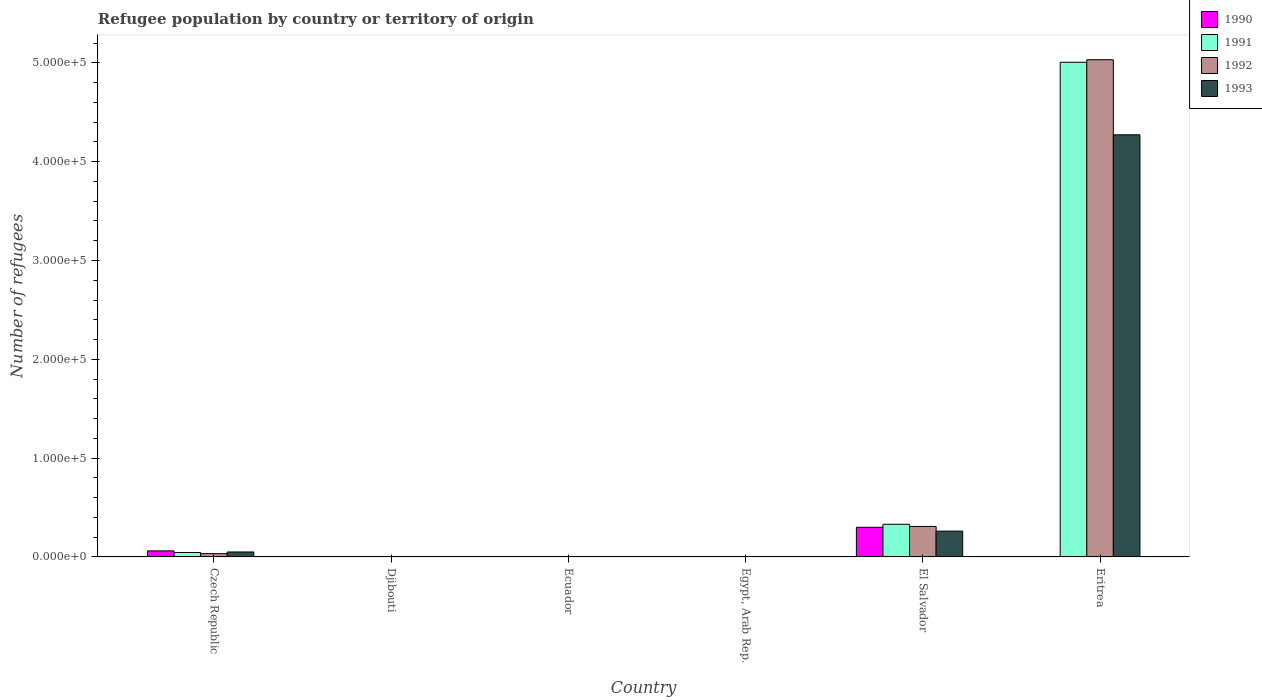How many different coloured bars are there?
Offer a very short reply. 4. Are the number of bars per tick equal to the number of legend labels?
Offer a very short reply. Yes. What is the label of the 4th group of bars from the left?
Make the answer very short. Egypt, Arab Rep. In how many cases, is the number of bars for a given country not equal to the number of legend labels?
Your answer should be compact. 0. Across all countries, what is the maximum number of refugees in 1990?
Make the answer very short. 3.00e+04. In which country was the number of refugees in 1990 maximum?
Offer a very short reply. El Salvador. In which country was the number of refugees in 1990 minimum?
Give a very brief answer. Ecuador. What is the total number of refugees in 1990 in the graph?
Your answer should be compact. 3.62e+04. What is the difference between the number of refugees in 1991 in Djibouti and that in Egypt, Arab Rep.?
Make the answer very short. -87. What is the difference between the number of refugees in 1992 in Czech Republic and the number of refugees in 1990 in Ecuador?
Offer a very short reply. 3324. What is the average number of refugees in 1990 per country?
Make the answer very short. 6040.17. What is the difference between the number of refugees of/in 1992 and number of refugees of/in 1991 in El Salvador?
Provide a short and direct response. -2194. In how many countries, is the number of refugees in 1991 greater than 360000?
Provide a short and direct response. 1. What is the ratio of the number of refugees in 1991 in Egypt, Arab Rep. to that in Eritrea?
Your answer should be compact. 0. Is the difference between the number of refugees in 1992 in Czech Republic and Eritrea greater than the difference between the number of refugees in 1991 in Czech Republic and Eritrea?
Your answer should be compact. No. What is the difference between the highest and the second highest number of refugees in 1993?
Your response must be concise. -4.01e+05. What is the difference between the highest and the lowest number of refugees in 1992?
Provide a succinct answer. 5.03e+05. Is it the case that in every country, the sum of the number of refugees in 1992 and number of refugees in 1993 is greater than the sum of number of refugees in 1990 and number of refugees in 1991?
Keep it short and to the point. No. What does the 3rd bar from the left in Czech Republic represents?
Offer a very short reply. 1992. What does the 1st bar from the right in Czech Republic represents?
Provide a succinct answer. 1993. How many bars are there?
Offer a very short reply. 24. Are all the bars in the graph horizontal?
Your response must be concise. No. How many countries are there in the graph?
Provide a short and direct response. 6. What is the difference between two consecutive major ticks on the Y-axis?
Provide a short and direct response. 1.00e+05. Are the values on the major ticks of Y-axis written in scientific E-notation?
Your answer should be very brief. Yes. Does the graph contain grids?
Provide a short and direct response. No. Where does the legend appear in the graph?
Your answer should be very brief. Top right. How many legend labels are there?
Provide a succinct answer. 4. What is the title of the graph?
Offer a very short reply. Refugee population by country or territory of origin. What is the label or title of the X-axis?
Keep it short and to the point. Country. What is the label or title of the Y-axis?
Offer a terse response. Number of refugees. What is the Number of refugees in 1990 in Czech Republic?
Provide a short and direct response. 6123. What is the Number of refugees in 1991 in Czech Republic?
Offer a very short reply. 4491. What is the Number of refugees in 1992 in Czech Republic?
Offer a terse response. 3327. What is the Number of refugees in 1993 in Czech Republic?
Your response must be concise. 5015. What is the Number of refugees in 1990 in Djibouti?
Give a very brief answer. 5. What is the Number of refugees in 1991 in Djibouti?
Your answer should be compact. 10. What is the Number of refugees in 1992 in Djibouti?
Offer a terse response. 11. What is the Number of refugees of 1993 in Djibouti?
Ensure brevity in your answer.  38. What is the Number of refugees in 1990 in Ecuador?
Offer a very short reply. 3. What is the Number of refugees of 1991 in Ecuador?
Give a very brief answer. 27. What is the Number of refugees in 1992 in Ecuador?
Provide a succinct answer. 40. What is the Number of refugees of 1993 in Ecuador?
Offer a terse response. 47. What is the Number of refugees of 1990 in Egypt, Arab Rep.?
Your answer should be compact. 48. What is the Number of refugees in 1991 in Egypt, Arab Rep.?
Keep it short and to the point. 97. What is the Number of refugees of 1992 in Egypt, Arab Rep.?
Provide a short and direct response. 209. What is the Number of refugees of 1993 in Egypt, Arab Rep.?
Your answer should be very brief. 258. What is the Number of refugees in 1990 in El Salvador?
Ensure brevity in your answer.  3.00e+04. What is the Number of refugees of 1991 in El Salvador?
Make the answer very short. 3.30e+04. What is the Number of refugees in 1992 in El Salvador?
Your answer should be very brief. 3.09e+04. What is the Number of refugees of 1993 in El Salvador?
Give a very brief answer. 2.61e+04. What is the Number of refugees of 1991 in Eritrea?
Provide a succinct answer. 5.01e+05. What is the Number of refugees in 1992 in Eritrea?
Ensure brevity in your answer.  5.03e+05. What is the Number of refugees of 1993 in Eritrea?
Offer a very short reply. 4.27e+05. Across all countries, what is the maximum Number of refugees in 1990?
Keep it short and to the point. 3.00e+04. Across all countries, what is the maximum Number of refugees in 1991?
Your answer should be very brief. 5.01e+05. Across all countries, what is the maximum Number of refugees of 1992?
Your answer should be very brief. 5.03e+05. Across all countries, what is the maximum Number of refugees in 1993?
Ensure brevity in your answer.  4.27e+05. Across all countries, what is the minimum Number of refugees in 1991?
Ensure brevity in your answer.  10. Across all countries, what is the minimum Number of refugees of 1993?
Provide a succinct answer. 38. What is the total Number of refugees in 1990 in the graph?
Your answer should be compact. 3.62e+04. What is the total Number of refugees in 1991 in the graph?
Your answer should be compact. 5.38e+05. What is the total Number of refugees in 1992 in the graph?
Offer a terse response. 5.38e+05. What is the total Number of refugees in 1993 in the graph?
Offer a very short reply. 4.59e+05. What is the difference between the Number of refugees in 1990 in Czech Republic and that in Djibouti?
Provide a succinct answer. 6118. What is the difference between the Number of refugees in 1991 in Czech Republic and that in Djibouti?
Your answer should be very brief. 4481. What is the difference between the Number of refugees of 1992 in Czech Republic and that in Djibouti?
Your response must be concise. 3316. What is the difference between the Number of refugees in 1993 in Czech Republic and that in Djibouti?
Give a very brief answer. 4977. What is the difference between the Number of refugees of 1990 in Czech Republic and that in Ecuador?
Your answer should be very brief. 6120. What is the difference between the Number of refugees in 1991 in Czech Republic and that in Ecuador?
Your response must be concise. 4464. What is the difference between the Number of refugees of 1992 in Czech Republic and that in Ecuador?
Offer a terse response. 3287. What is the difference between the Number of refugees of 1993 in Czech Republic and that in Ecuador?
Offer a very short reply. 4968. What is the difference between the Number of refugees in 1990 in Czech Republic and that in Egypt, Arab Rep.?
Your answer should be very brief. 6075. What is the difference between the Number of refugees in 1991 in Czech Republic and that in Egypt, Arab Rep.?
Your response must be concise. 4394. What is the difference between the Number of refugees of 1992 in Czech Republic and that in Egypt, Arab Rep.?
Give a very brief answer. 3118. What is the difference between the Number of refugees of 1993 in Czech Republic and that in Egypt, Arab Rep.?
Your response must be concise. 4757. What is the difference between the Number of refugees in 1990 in Czech Republic and that in El Salvador?
Provide a succinct answer. -2.39e+04. What is the difference between the Number of refugees of 1991 in Czech Republic and that in El Salvador?
Your answer should be compact. -2.86e+04. What is the difference between the Number of refugees in 1992 in Czech Republic and that in El Salvador?
Offer a very short reply. -2.75e+04. What is the difference between the Number of refugees of 1993 in Czech Republic and that in El Salvador?
Make the answer very short. -2.11e+04. What is the difference between the Number of refugees of 1990 in Czech Republic and that in Eritrea?
Keep it short and to the point. 6080. What is the difference between the Number of refugees in 1991 in Czech Republic and that in Eritrea?
Your response must be concise. -4.96e+05. What is the difference between the Number of refugees in 1992 in Czech Republic and that in Eritrea?
Your answer should be very brief. -5.00e+05. What is the difference between the Number of refugees in 1993 in Czech Republic and that in Eritrea?
Offer a very short reply. -4.22e+05. What is the difference between the Number of refugees in 1990 in Djibouti and that in Ecuador?
Your response must be concise. 2. What is the difference between the Number of refugees of 1991 in Djibouti and that in Ecuador?
Offer a very short reply. -17. What is the difference between the Number of refugees in 1993 in Djibouti and that in Ecuador?
Your answer should be very brief. -9. What is the difference between the Number of refugees of 1990 in Djibouti and that in Egypt, Arab Rep.?
Make the answer very short. -43. What is the difference between the Number of refugees of 1991 in Djibouti and that in Egypt, Arab Rep.?
Your answer should be compact. -87. What is the difference between the Number of refugees in 1992 in Djibouti and that in Egypt, Arab Rep.?
Your answer should be compact. -198. What is the difference between the Number of refugees in 1993 in Djibouti and that in Egypt, Arab Rep.?
Your answer should be compact. -220. What is the difference between the Number of refugees in 1990 in Djibouti and that in El Salvador?
Give a very brief answer. -3.00e+04. What is the difference between the Number of refugees of 1991 in Djibouti and that in El Salvador?
Offer a very short reply. -3.30e+04. What is the difference between the Number of refugees of 1992 in Djibouti and that in El Salvador?
Provide a succinct answer. -3.08e+04. What is the difference between the Number of refugees of 1993 in Djibouti and that in El Salvador?
Your answer should be compact. -2.61e+04. What is the difference between the Number of refugees in 1990 in Djibouti and that in Eritrea?
Offer a very short reply. -38. What is the difference between the Number of refugees in 1991 in Djibouti and that in Eritrea?
Provide a short and direct response. -5.01e+05. What is the difference between the Number of refugees in 1992 in Djibouti and that in Eritrea?
Provide a succinct answer. -5.03e+05. What is the difference between the Number of refugees in 1993 in Djibouti and that in Eritrea?
Your answer should be compact. -4.27e+05. What is the difference between the Number of refugees of 1990 in Ecuador and that in Egypt, Arab Rep.?
Give a very brief answer. -45. What is the difference between the Number of refugees in 1991 in Ecuador and that in Egypt, Arab Rep.?
Your response must be concise. -70. What is the difference between the Number of refugees of 1992 in Ecuador and that in Egypt, Arab Rep.?
Provide a succinct answer. -169. What is the difference between the Number of refugees of 1993 in Ecuador and that in Egypt, Arab Rep.?
Keep it short and to the point. -211. What is the difference between the Number of refugees of 1990 in Ecuador and that in El Salvador?
Ensure brevity in your answer.  -3.00e+04. What is the difference between the Number of refugees in 1991 in Ecuador and that in El Salvador?
Provide a succinct answer. -3.30e+04. What is the difference between the Number of refugees of 1992 in Ecuador and that in El Salvador?
Provide a short and direct response. -3.08e+04. What is the difference between the Number of refugees of 1993 in Ecuador and that in El Salvador?
Give a very brief answer. -2.61e+04. What is the difference between the Number of refugees in 1991 in Ecuador and that in Eritrea?
Offer a very short reply. -5.01e+05. What is the difference between the Number of refugees in 1992 in Ecuador and that in Eritrea?
Provide a succinct answer. -5.03e+05. What is the difference between the Number of refugees in 1993 in Ecuador and that in Eritrea?
Your answer should be compact. -4.27e+05. What is the difference between the Number of refugees in 1990 in Egypt, Arab Rep. and that in El Salvador?
Provide a succinct answer. -3.00e+04. What is the difference between the Number of refugees of 1991 in Egypt, Arab Rep. and that in El Salvador?
Offer a very short reply. -3.30e+04. What is the difference between the Number of refugees of 1992 in Egypt, Arab Rep. and that in El Salvador?
Your answer should be compact. -3.06e+04. What is the difference between the Number of refugees in 1993 in Egypt, Arab Rep. and that in El Salvador?
Keep it short and to the point. -2.59e+04. What is the difference between the Number of refugees of 1990 in Egypt, Arab Rep. and that in Eritrea?
Your answer should be very brief. 5. What is the difference between the Number of refugees in 1991 in Egypt, Arab Rep. and that in Eritrea?
Your answer should be compact. -5.01e+05. What is the difference between the Number of refugees in 1992 in Egypt, Arab Rep. and that in Eritrea?
Offer a very short reply. -5.03e+05. What is the difference between the Number of refugees in 1993 in Egypt, Arab Rep. and that in Eritrea?
Your response must be concise. -4.27e+05. What is the difference between the Number of refugees of 1990 in El Salvador and that in Eritrea?
Give a very brief answer. 3.00e+04. What is the difference between the Number of refugees of 1991 in El Salvador and that in Eritrea?
Make the answer very short. -4.68e+05. What is the difference between the Number of refugees of 1992 in El Salvador and that in Eritrea?
Your answer should be compact. -4.72e+05. What is the difference between the Number of refugees of 1993 in El Salvador and that in Eritrea?
Provide a short and direct response. -4.01e+05. What is the difference between the Number of refugees in 1990 in Czech Republic and the Number of refugees in 1991 in Djibouti?
Your answer should be very brief. 6113. What is the difference between the Number of refugees in 1990 in Czech Republic and the Number of refugees in 1992 in Djibouti?
Your answer should be very brief. 6112. What is the difference between the Number of refugees in 1990 in Czech Republic and the Number of refugees in 1993 in Djibouti?
Make the answer very short. 6085. What is the difference between the Number of refugees of 1991 in Czech Republic and the Number of refugees of 1992 in Djibouti?
Offer a very short reply. 4480. What is the difference between the Number of refugees of 1991 in Czech Republic and the Number of refugees of 1993 in Djibouti?
Your answer should be very brief. 4453. What is the difference between the Number of refugees of 1992 in Czech Republic and the Number of refugees of 1993 in Djibouti?
Offer a very short reply. 3289. What is the difference between the Number of refugees of 1990 in Czech Republic and the Number of refugees of 1991 in Ecuador?
Offer a terse response. 6096. What is the difference between the Number of refugees in 1990 in Czech Republic and the Number of refugees in 1992 in Ecuador?
Your answer should be compact. 6083. What is the difference between the Number of refugees in 1990 in Czech Republic and the Number of refugees in 1993 in Ecuador?
Offer a terse response. 6076. What is the difference between the Number of refugees in 1991 in Czech Republic and the Number of refugees in 1992 in Ecuador?
Ensure brevity in your answer.  4451. What is the difference between the Number of refugees in 1991 in Czech Republic and the Number of refugees in 1993 in Ecuador?
Provide a short and direct response. 4444. What is the difference between the Number of refugees in 1992 in Czech Republic and the Number of refugees in 1993 in Ecuador?
Your response must be concise. 3280. What is the difference between the Number of refugees in 1990 in Czech Republic and the Number of refugees in 1991 in Egypt, Arab Rep.?
Provide a succinct answer. 6026. What is the difference between the Number of refugees of 1990 in Czech Republic and the Number of refugees of 1992 in Egypt, Arab Rep.?
Ensure brevity in your answer.  5914. What is the difference between the Number of refugees in 1990 in Czech Republic and the Number of refugees in 1993 in Egypt, Arab Rep.?
Your answer should be very brief. 5865. What is the difference between the Number of refugees in 1991 in Czech Republic and the Number of refugees in 1992 in Egypt, Arab Rep.?
Provide a short and direct response. 4282. What is the difference between the Number of refugees of 1991 in Czech Republic and the Number of refugees of 1993 in Egypt, Arab Rep.?
Provide a short and direct response. 4233. What is the difference between the Number of refugees of 1992 in Czech Republic and the Number of refugees of 1993 in Egypt, Arab Rep.?
Your answer should be very brief. 3069. What is the difference between the Number of refugees of 1990 in Czech Republic and the Number of refugees of 1991 in El Salvador?
Your answer should be very brief. -2.69e+04. What is the difference between the Number of refugees in 1990 in Czech Republic and the Number of refugees in 1992 in El Salvador?
Your answer should be very brief. -2.47e+04. What is the difference between the Number of refugees of 1990 in Czech Republic and the Number of refugees of 1993 in El Salvador?
Your answer should be very brief. -2.00e+04. What is the difference between the Number of refugees in 1991 in Czech Republic and the Number of refugees in 1992 in El Salvador?
Offer a terse response. -2.64e+04. What is the difference between the Number of refugees in 1991 in Czech Republic and the Number of refugees in 1993 in El Salvador?
Offer a terse response. -2.16e+04. What is the difference between the Number of refugees of 1992 in Czech Republic and the Number of refugees of 1993 in El Salvador?
Your response must be concise. -2.28e+04. What is the difference between the Number of refugees in 1990 in Czech Republic and the Number of refugees in 1991 in Eritrea?
Ensure brevity in your answer.  -4.95e+05. What is the difference between the Number of refugees in 1990 in Czech Republic and the Number of refugees in 1992 in Eritrea?
Your answer should be very brief. -4.97e+05. What is the difference between the Number of refugees of 1990 in Czech Republic and the Number of refugees of 1993 in Eritrea?
Your answer should be compact. -4.21e+05. What is the difference between the Number of refugees of 1991 in Czech Republic and the Number of refugees of 1992 in Eritrea?
Offer a very short reply. -4.99e+05. What is the difference between the Number of refugees of 1991 in Czech Republic and the Number of refugees of 1993 in Eritrea?
Make the answer very short. -4.23e+05. What is the difference between the Number of refugees of 1992 in Czech Republic and the Number of refugees of 1993 in Eritrea?
Your response must be concise. -4.24e+05. What is the difference between the Number of refugees in 1990 in Djibouti and the Number of refugees in 1991 in Ecuador?
Your response must be concise. -22. What is the difference between the Number of refugees in 1990 in Djibouti and the Number of refugees in 1992 in Ecuador?
Make the answer very short. -35. What is the difference between the Number of refugees in 1990 in Djibouti and the Number of refugees in 1993 in Ecuador?
Your answer should be compact. -42. What is the difference between the Number of refugees of 1991 in Djibouti and the Number of refugees of 1992 in Ecuador?
Offer a terse response. -30. What is the difference between the Number of refugees in 1991 in Djibouti and the Number of refugees in 1993 in Ecuador?
Provide a short and direct response. -37. What is the difference between the Number of refugees in 1992 in Djibouti and the Number of refugees in 1993 in Ecuador?
Offer a terse response. -36. What is the difference between the Number of refugees in 1990 in Djibouti and the Number of refugees in 1991 in Egypt, Arab Rep.?
Offer a terse response. -92. What is the difference between the Number of refugees in 1990 in Djibouti and the Number of refugees in 1992 in Egypt, Arab Rep.?
Your answer should be compact. -204. What is the difference between the Number of refugees of 1990 in Djibouti and the Number of refugees of 1993 in Egypt, Arab Rep.?
Ensure brevity in your answer.  -253. What is the difference between the Number of refugees of 1991 in Djibouti and the Number of refugees of 1992 in Egypt, Arab Rep.?
Keep it short and to the point. -199. What is the difference between the Number of refugees of 1991 in Djibouti and the Number of refugees of 1993 in Egypt, Arab Rep.?
Keep it short and to the point. -248. What is the difference between the Number of refugees of 1992 in Djibouti and the Number of refugees of 1993 in Egypt, Arab Rep.?
Provide a short and direct response. -247. What is the difference between the Number of refugees of 1990 in Djibouti and the Number of refugees of 1991 in El Salvador?
Give a very brief answer. -3.30e+04. What is the difference between the Number of refugees in 1990 in Djibouti and the Number of refugees in 1992 in El Salvador?
Your answer should be compact. -3.08e+04. What is the difference between the Number of refugees of 1990 in Djibouti and the Number of refugees of 1993 in El Salvador?
Keep it short and to the point. -2.61e+04. What is the difference between the Number of refugees of 1991 in Djibouti and the Number of refugees of 1992 in El Salvador?
Ensure brevity in your answer.  -3.08e+04. What is the difference between the Number of refugees of 1991 in Djibouti and the Number of refugees of 1993 in El Salvador?
Your answer should be compact. -2.61e+04. What is the difference between the Number of refugees of 1992 in Djibouti and the Number of refugees of 1993 in El Salvador?
Ensure brevity in your answer.  -2.61e+04. What is the difference between the Number of refugees in 1990 in Djibouti and the Number of refugees in 1991 in Eritrea?
Offer a terse response. -5.01e+05. What is the difference between the Number of refugees in 1990 in Djibouti and the Number of refugees in 1992 in Eritrea?
Your answer should be very brief. -5.03e+05. What is the difference between the Number of refugees of 1990 in Djibouti and the Number of refugees of 1993 in Eritrea?
Your response must be concise. -4.27e+05. What is the difference between the Number of refugees in 1991 in Djibouti and the Number of refugees in 1992 in Eritrea?
Offer a terse response. -5.03e+05. What is the difference between the Number of refugees of 1991 in Djibouti and the Number of refugees of 1993 in Eritrea?
Give a very brief answer. -4.27e+05. What is the difference between the Number of refugees in 1992 in Djibouti and the Number of refugees in 1993 in Eritrea?
Offer a terse response. -4.27e+05. What is the difference between the Number of refugees of 1990 in Ecuador and the Number of refugees of 1991 in Egypt, Arab Rep.?
Your answer should be compact. -94. What is the difference between the Number of refugees in 1990 in Ecuador and the Number of refugees in 1992 in Egypt, Arab Rep.?
Keep it short and to the point. -206. What is the difference between the Number of refugees of 1990 in Ecuador and the Number of refugees of 1993 in Egypt, Arab Rep.?
Provide a succinct answer. -255. What is the difference between the Number of refugees in 1991 in Ecuador and the Number of refugees in 1992 in Egypt, Arab Rep.?
Keep it short and to the point. -182. What is the difference between the Number of refugees of 1991 in Ecuador and the Number of refugees of 1993 in Egypt, Arab Rep.?
Make the answer very short. -231. What is the difference between the Number of refugees in 1992 in Ecuador and the Number of refugees in 1993 in Egypt, Arab Rep.?
Offer a very short reply. -218. What is the difference between the Number of refugees of 1990 in Ecuador and the Number of refugees of 1991 in El Salvador?
Offer a very short reply. -3.30e+04. What is the difference between the Number of refugees of 1990 in Ecuador and the Number of refugees of 1992 in El Salvador?
Ensure brevity in your answer.  -3.09e+04. What is the difference between the Number of refugees of 1990 in Ecuador and the Number of refugees of 1993 in El Salvador?
Your response must be concise. -2.61e+04. What is the difference between the Number of refugees in 1991 in Ecuador and the Number of refugees in 1992 in El Salvador?
Ensure brevity in your answer.  -3.08e+04. What is the difference between the Number of refugees of 1991 in Ecuador and the Number of refugees of 1993 in El Salvador?
Offer a terse response. -2.61e+04. What is the difference between the Number of refugees of 1992 in Ecuador and the Number of refugees of 1993 in El Salvador?
Offer a very short reply. -2.61e+04. What is the difference between the Number of refugees in 1990 in Ecuador and the Number of refugees in 1991 in Eritrea?
Provide a short and direct response. -5.01e+05. What is the difference between the Number of refugees in 1990 in Ecuador and the Number of refugees in 1992 in Eritrea?
Your answer should be compact. -5.03e+05. What is the difference between the Number of refugees in 1990 in Ecuador and the Number of refugees in 1993 in Eritrea?
Give a very brief answer. -4.27e+05. What is the difference between the Number of refugees of 1991 in Ecuador and the Number of refugees of 1992 in Eritrea?
Give a very brief answer. -5.03e+05. What is the difference between the Number of refugees in 1991 in Ecuador and the Number of refugees in 1993 in Eritrea?
Your answer should be compact. -4.27e+05. What is the difference between the Number of refugees in 1992 in Ecuador and the Number of refugees in 1993 in Eritrea?
Offer a very short reply. -4.27e+05. What is the difference between the Number of refugees of 1990 in Egypt, Arab Rep. and the Number of refugees of 1991 in El Salvador?
Your answer should be very brief. -3.30e+04. What is the difference between the Number of refugees of 1990 in Egypt, Arab Rep. and the Number of refugees of 1992 in El Salvador?
Offer a terse response. -3.08e+04. What is the difference between the Number of refugees of 1990 in Egypt, Arab Rep. and the Number of refugees of 1993 in El Salvador?
Make the answer very short. -2.61e+04. What is the difference between the Number of refugees in 1991 in Egypt, Arab Rep. and the Number of refugees in 1992 in El Salvador?
Offer a terse response. -3.08e+04. What is the difference between the Number of refugees of 1991 in Egypt, Arab Rep. and the Number of refugees of 1993 in El Salvador?
Keep it short and to the point. -2.60e+04. What is the difference between the Number of refugees of 1992 in Egypt, Arab Rep. and the Number of refugees of 1993 in El Salvador?
Your answer should be very brief. -2.59e+04. What is the difference between the Number of refugees in 1990 in Egypt, Arab Rep. and the Number of refugees in 1991 in Eritrea?
Your answer should be very brief. -5.01e+05. What is the difference between the Number of refugees in 1990 in Egypt, Arab Rep. and the Number of refugees in 1992 in Eritrea?
Keep it short and to the point. -5.03e+05. What is the difference between the Number of refugees of 1990 in Egypt, Arab Rep. and the Number of refugees of 1993 in Eritrea?
Offer a very short reply. -4.27e+05. What is the difference between the Number of refugees of 1991 in Egypt, Arab Rep. and the Number of refugees of 1992 in Eritrea?
Make the answer very short. -5.03e+05. What is the difference between the Number of refugees of 1991 in Egypt, Arab Rep. and the Number of refugees of 1993 in Eritrea?
Ensure brevity in your answer.  -4.27e+05. What is the difference between the Number of refugees in 1992 in Egypt, Arab Rep. and the Number of refugees in 1993 in Eritrea?
Ensure brevity in your answer.  -4.27e+05. What is the difference between the Number of refugees in 1990 in El Salvador and the Number of refugees in 1991 in Eritrea?
Provide a short and direct response. -4.71e+05. What is the difference between the Number of refugees of 1990 in El Salvador and the Number of refugees of 1992 in Eritrea?
Make the answer very short. -4.73e+05. What is the difference between the Number of refugees in 1990 in El Salvador and the Number of refugees in 1993 in Eritrea?
Give a very brief answer. -3.97e+05. What is the difference between the Number of refugees of 1991 in El Salvador and the Number of refugees of 1992 in Eritrea?
Provide a succinct answer. -4.70e+05. What is the difference between the Number of refugees in 1991 in El Salvador and the Number of refugees in 1993 in Eritrea?
Make the answer very short. -3.94e+05. What is the difference between the Number of refugees of 1992 in El Salvador and the Number of refugees of 1993 in Eritrea?
Your response must be concise. -3.96e+05. What is the average Number of refugees of 1990 per country?
Ensure brevity in your answer.  6040.17. What is the average Number of refugees in 1991 per country?
Provide a short and direct response. 8.97e+04. What is the average Number of refugees in 1992 per country?
Your response must be concise. 8.96e+04. What is the average Number of refugees of 1993 per country?
Your answer should be compact. 7.64e+04. What is the difference between the Number of refugees in 1990 and Number of refugees in 1991 in Czech Republic?
Your response must be concise. 1632. What is the difference between the Number of refugees in 1990 and Number of refugees in 1992 in Czech Republic?
Give a very brief answer. 2796. What is the difference between the Number of refugees of 1990 and Number of refugees of 1993 in Czech Republic?
Provide a short and direct response. 1108. What is the difference between the Number of refugees in 1991 and Number of refugees in 1992 in Czech Republic?
Provide a succinct answer. 1164. What is the difference between the Number of refugees in 1991 and Number of refugees in 1993 in Czech Republic?
Ensure brevity in your answer.  -524. What is the difference between the Number of refugees in 1992 and Number of refugees in 1993 in Czech Republic?
Offer a very short reply. -1688. What is the difference between the Number of refugees in 1990 and Number of refugees in 1993 in Djibouti?
Provide a short and direct response. -33. What is the difference between the Number of refugees in 1991 and Number of refugees in 1993 in Djibouti?
Your answer should be compact. -28. What is the difference between the Number of refugees of 1992 and Number of refugees of 1993 in Djibouti?
Keep it short and to the point. -27. What is the difference between the Number of refugees of 1990 and Number of refugees of 1991 in Ecuador?
Provide a short and direct response. -24. What is the difference between the Number of refugees in 1990 and Number of refugees in 1992 in Ecuador?
Offer a terse response. -37. What is the difference between the Number of refugees in 1990 and Number of refugees in 1993 in Ecuador?
Offer a very short reply. -44. What is the difference between the Number of refugees in 1991 and Number of refugees in 1993 in Ecuador?
Give a very brief answer. -20. What is the difference between the Number of refugees of 1992 and Number of refugees of 1993 in Ecuador?
Your response must be concise. -7. What is the difference between the Number of refugees in 1990 and Number of refugees in 1991 in Egypt, Arab Rep.?
Give a very brief answer. -49. What is the difference between the Number of refugees in 1990 and Number of refugees in 1992 in Egypt, Arab Rep.?
Your answer should be very brief. -161. What is the difference between the Number of refugees in 1990 and Number of refugees in 1993 in Egypt, Arab Rep.?
Provide a succinct answer. -210. What is the difference between the Number of refugees in 1991 and Number of refugees in 1992 in Egypt, Arab Rep.?
Give a very brief answer. -112. What is the difference between the Number of refugees of 1991 and Number of refugees of 1993 in Egypt, Arab Rep.?
Provide a succinct answer. -161. What is the difference between the Number of refugees of 1992 and Number of refugees of 1993 in Egypt, Arab Rep.?
Keep it short and to the point. -49. What is the difference between the Number of refugees of 1990 and Number of refugees of 1991 in El Salvador?
Offer a terse response. -3030. What is the difference between the Number of refugees in 1990 and Number of refugees in 1992 in El Salvador?
Give a very brief answer. -836. What is the difference between the Number of refugees of 1990 and Number of refugees of 1993 in El Salvador?
Make the answer very short. 3895. What is the difference between the Number of refugees in 1991 and Number of refugees in 1992 in El Salvador?
Provide a short and direct response. 2194. What is the difference between the Number of refugees of 1991 and Number of refugees of 1993 in El Salvador?
Your answer should be compact. 6925. What is the difference between the Number of refugees in 1992 and Number of refugees in 1993 in El Salvador?
Offer a terse response. 4731. What is the difference between the Number of refugees of 1990 and Number of refugees of 1991 in Eritrea?
Offer a terse response. -5.01e+05. What is the difference between the Number of refugees in 1990 and Number of refugees in 1992 in Eritrea?
Give a very brief answer. -5.03e+05. What is the difference between the Number of refugees in 1990 and Number of refugees in 1993 in Eritrea?
Offer a terse response. -4.27e+05. What is the difference between the Number of refugees of 1991 and Number of refugees of 1992 in Eritrea?
Offer a very short reply. -2567. What is the difference between the Number of refugees of 1991 and Number of refugees of 1993 in Eritrea?
Offer a very short reply. 7.34e+04. What is the difference between the Number of refugees in 1992 and Number of refugees in 1993 in Eritrea?
Keep it short and to the point. 7.60e+04. What is the ratio of the Number of refugees in 1990 in Czech Republic to that in Djibouti?
Make the answer very short. 1224.6. What is the ratio of the Number of refugees of 1991 in Czech Republic to that in Djibouti?
Give a very brief answer. 449.1. What is the ratio of the Number of refugees of 1992 in Czech Republic to that in Djibouti?
Provide a short and direct response. 302.45. What is the ratio of the Number of refugees of 1993 in Czech Republic to that in Djibouti?
Your answer should be very brief. 131.97. What is the ratio of the Number of refugees in 1990 in Czech Republic to that in Ecuador?
Provide a succinct answer. 2041. What is the ratio of the Number of refugees of 1991 in Czech Republic to that in Ecuador?
Ensure brevity in your answer.  166.33. What is the ratio of the Number of refugees in 1992 in Czech Republic to that in Ecuador?
Make the answer very short. 83.17. What is the ratio of the Number of refugees of 1993 in Czech Republic to that in Ecuador?
Your response must be concise. 106.7. What is the ratio of the Number of refugees in 1990 in Czech Republic to that in Egypt, Arab Rep.?
Offer a very short reply. 127.56. What is the ratio of the Number of refugees in 1991 in Czech Republic to that in Egypt, Arab Rep.?
Keep it short and to the point. 46.3. What is the ratio of the Number of refugees in 1992 in Czech Republic to that in Egypt, Arab Rep.?
Ensure brevity in your answer.  15.92. What is the ratio of the Number of refugees in 1993 in Czech Republic to that in Egypt, Arab Rep.?
Provide a succinct answer. 19.44. What is the ratio of the Number of refugees of 1990 in Czech Republic to that in El Salvador?
Offer a very short reply. 0.2. What is the ratio of the Number of refugees in 1991 in Czech Republic to that in El Salvador?
Keep it short and to the point. 0.14. What is the ratio of the Number of refugees in 1992 in Czech Republic to that in El Salvador?
Your answer should be compact. 0.11. What is the ratio of the Number of refugees in 1993 in Czech Republic to that in El Salvador?
Keep it short and to the point. 0.19. What is the ratio of the Number of refugees of 1990 in Czech Republic to that in Eritrea?
Your answer should be very brief. 142.4. What is the ratio of the Number of refugees of 1991 in Czech Republic to that in Eritrea?
Provide a short and direct response. 0.01. What is the ratio of the Number of refugees of 1992 in Czech Republic to that in Eritrea?
Ensure brevity in your answer.  0.01. What is the ratio of the Number of refugees of 1993 in Czech Republic to that in Eritrea?
Your answer should be very brief. 0.01. What is the ratio of the Number of refugees of 1991 in Djibouti to that in Ecuador?
Offer a terse response. 0.37. What is the ratio of the Number of refugees of 1992 in Djibouti to that in Ecuador?
Make the answer very short. 0.28. What is the ratio of the Number of refugees in 1993 in Djibouti to that in Ecuador?
Make the answer very short. 0.81. What is the ratio of the Number of refugees in 1990 in Djibouti to that in Egypt, Arab Rep.?
Your answer should be very brief. 0.1. What is the ratio of the Number of refugees in 1991 in Djibouti to that in Egypt, Arab Rep.?
Your answer should be very brief. 0.1. What is the ratio of the Number of refugees in 1992 in Djibouti to that in Egypt, Arab Rep.?
Provide a succinct answer. 0.05. What is the ratio of the Number of refugees in 1993 in Djibouti to that in Egypt, Arab Rep.?
Keep it short and to the point. 0.15. What is the ratio of the Number of refugees of 1991 in Djibouti to that in El Salvador?
Make the answer very short. 0. What is the ratio of the Number of refugees of 1992 in Djibouti to that in El Salvador?
Offer a very short reply. 0. What is the ratio of the Number of refugees in 1993 in Djibouti to that in El Salvador?
Give a very brief answer. 0. What is the ratio of the Number of refugees in 1990 in Djibouti to that in Eritrea?
Your response must be concise. 0.12. What is the ratio of the Number of refugees of 1992 in Djibouti to that in Eritrea?
Give a very brief answer. 0. What is the ratio of the Number of refugees of 1990 in Ecuador to that in Egypt, Arab Rep.?
Offer a very short reply. 0.06. What is the ratio of the Number of refugees of 1991 in Ecuador to that in Egypt, Arab Rep.?
Provide a succinct answer. 0.28. What is the ratio of the Number of refugees of 1992 in Ecuador to that in Egypt, Arab Rep.?
Ensure brevity in your answer.  0.19. What is the ratio of the Number of refugees in 1993 in Ecuador to that in Egypt, Arab Rep.?
Provide a succinct answer. 0.18. What is the ratio of the Number of refugees in 1991 in Ecuador to that in El Salvador?
Your answer should be very brief. 0. What is the ratio of the Number of refugees in 1992 in Ecuador to that in El Salvador?
Provide a short and direct response. 0. What is the ratio of the Number of refugees of 1993 in Ecuador to that in El Salvador?
Provide a succinct answer. 0. What is the ratio of the Number of refugees of 1990 in Ecuador to that in Eritrea?
Your response must be concise. 0.07. What is the ratio of the Number of refugees of 1991 in Ecuador to that in Eritrea?
Offer a terse response. 0. What is the ratio of the Number of refugees of 1993 in Ecuador to that in Eritrea?
Offer a very short reply. 0. What is the ratio of the Number of refugees in 1990 in Egypt, Arab Rep. to that in El Salvador?
Keep it short and to the point. 0. What is the ratio of the Number of refugees in 1991 in Egypt, Arab Rep. to that in El Salvador?
Give a very brief answer. 0. What is the ratio of the Number of refugees of 1992 in Egypt, Arab Rep. to that in El Salvador?
Offer a very short reply. 0.01. What is the ratio of the Number of refugees of 1993 in Egypt, Arab Rep. to that in El Salvador?
Your answer should be very brief. 0.01. What is the ratio of the Number of refugees in 1990 in Egypt, Arab Rep. to that in Eritrea?
Make the answer very short. 1.12. What is the ratio of the Number of refugees in 1992 in Egypt, Arab Rep. to that in Eritrea?
Your answer should be compact. 0. What is the ratio of the Number of refugees of 1993 in Egypt, Arab Rep. to that in Eritrea?
Give a very brief answer. 0. What is the ratio of the Number of refugees of 1990 in El Salvador to that in Eritrea?
Offer a terse response. 698.12. What is the ratio of the Number of refugees in 1991 in El Salvador to that in Eritrea?
Make the answer very short. 0.07. What is the ratio of the Number of refugees in 1992 in El Salvador to that in Eritrea?
Ensure brevity in your answer.  0.06. What is the ratio of the Number of refugees in 1993 in El Salvador to that in Eritrea?
Give a very brief answer. 0.06. What is the difference between the highest and the second highest Number of refugees of 1990?
Provide a short and direct response. 2.39e+04. What is the difference between the highest and the second highest Number of refugees of 1991?
Offer a terse response. 4.68e+05. What is the difference between the highest and the second highest Number of refugees of 1992?
Ensure brevity in your answer.  4.72e+05. What is the difference between the highest and the second highest Number of refugees of 1993?
Make the answer very short. 4.01e+05. What is the difference between the highest and the lowest Number of refugees in 1990?
Your response must be concise. 3.00e+04. What is the difference between the highest and the lowest Number of refugees of 1991?
Offer a terse response. 5.01e+05. What is the difference between the highest and the lowest Number of refugees in 1992?
Your response must be concise. 5.03e+05. What is the difference between the highest and the lowest Number of refugees in 1993?
Provide a short and direct response. 4.27e+05. 